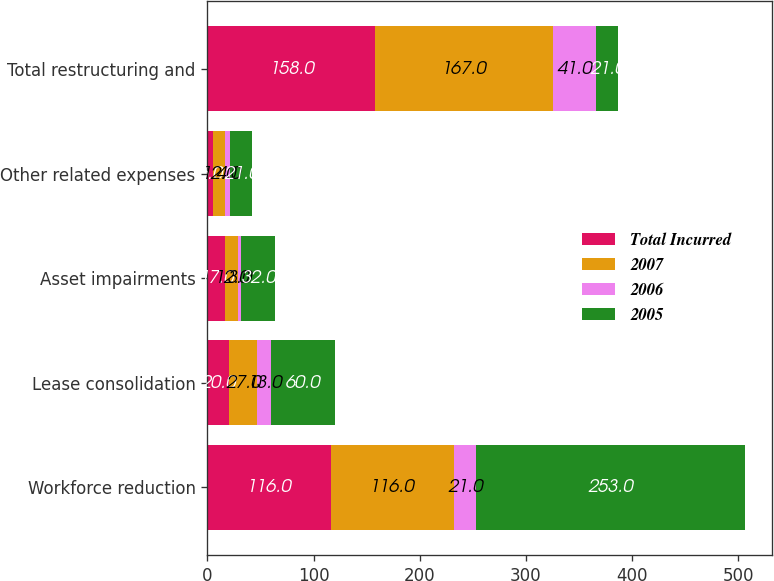Convert chart. <chart><loc_0><loc_0><loc_500><loc_500><stacked_bar_chart><ecel><fcel>Workforce reduction<fcel>Lease consolidation<fcel>Asset impairments<fcel>Other related expenses<fcel>Total restructuring and<nl><fcel>Total Incurred<fcel>116<fcel>20<fcel>17<fcel>5<fcel>158<nl><fcel>2007<fcel>116<fcel>27<fcel>12<fcel>12<fcel>167<nl><fcel>2006<fcel>21<fcel>13<fcel>3<fcel>4<fcel>41<nl><fcel>2005<fcel>253<fcel>60<fcel>32<fcel>21<fcel>21<nl></chart> 